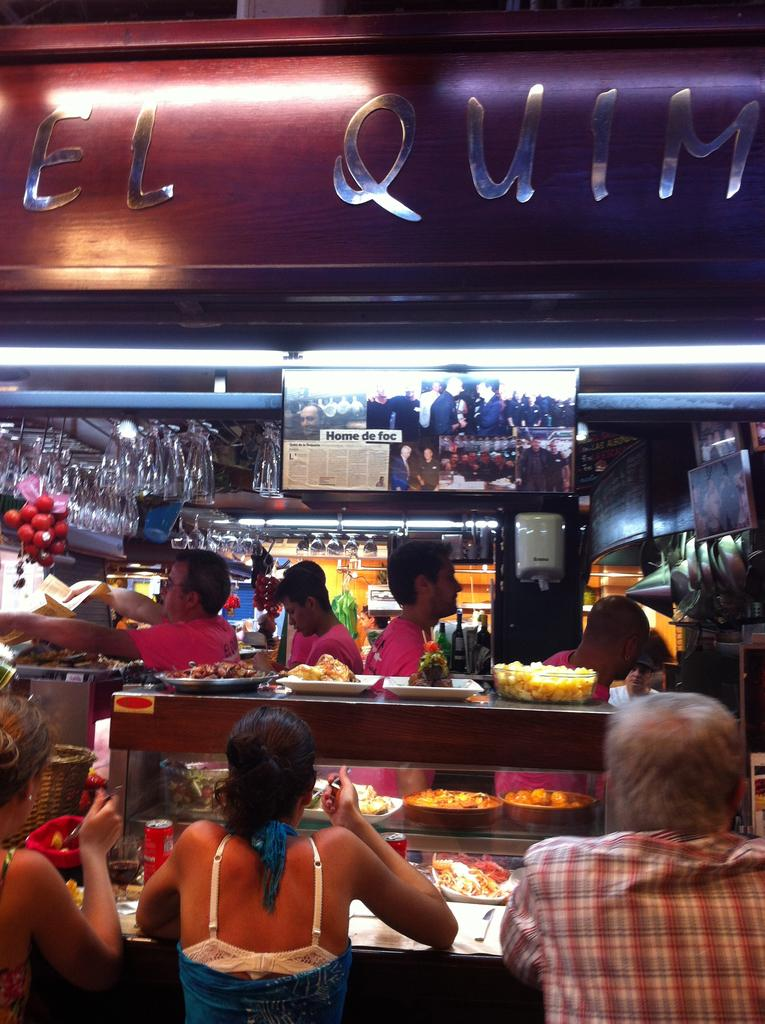Who or what can be seen in the image? There are people in the image. What else is present in the image besides the people? There are food items and a wooden object in the image. Can you describe the wooden object? Unfortunately, the facts provided do not give enough detail to describe the wooden object. What is the purpose of the name board in the image? The purpose of the name board in the image is to display a name or title. What type of glass is being used to serve the food in the image? There is no glass present in the image; the facts provided do not mention any glassware. 